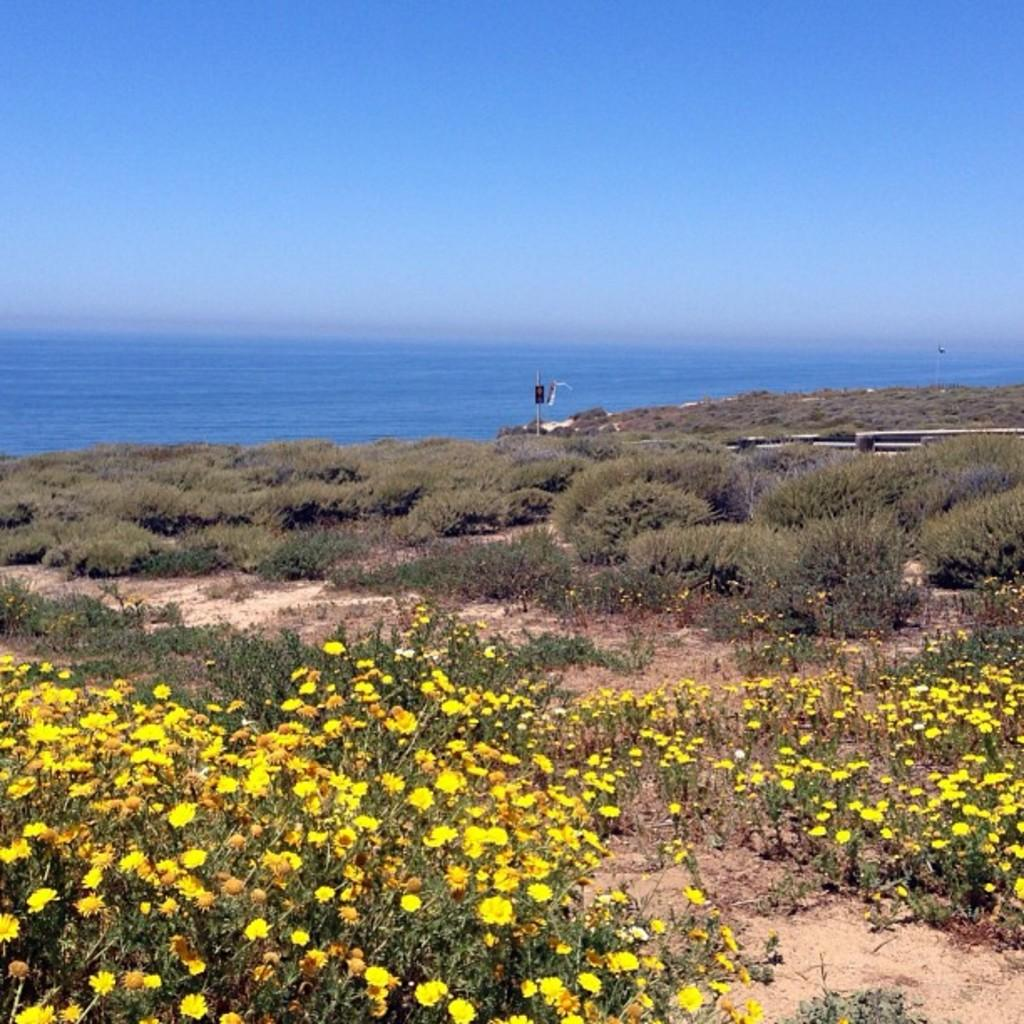What type of plants are present in the image? There are plants with flowers on the ground in the image. What natural feature can be seen in the background of the image? The background of the image includes the sea. What else is visible in the background of the image? The sky is visible in the background of the image. What type of key is used to unlock the question in the image? There is no key or question present in the image; it features plants with flowers and a background with the sea and sky. 